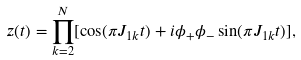<formula> <loc_0><loc_0><loc_500><loc_500>z ( t ) = \prod _ { k = 2 } ^ { N } [ \cos ( \pi J _ { 1 k } t ) + i \phi _ { + } \phi _ { - } \sin ( \pi J _ { 1 k } t ) ] ,</formula> 